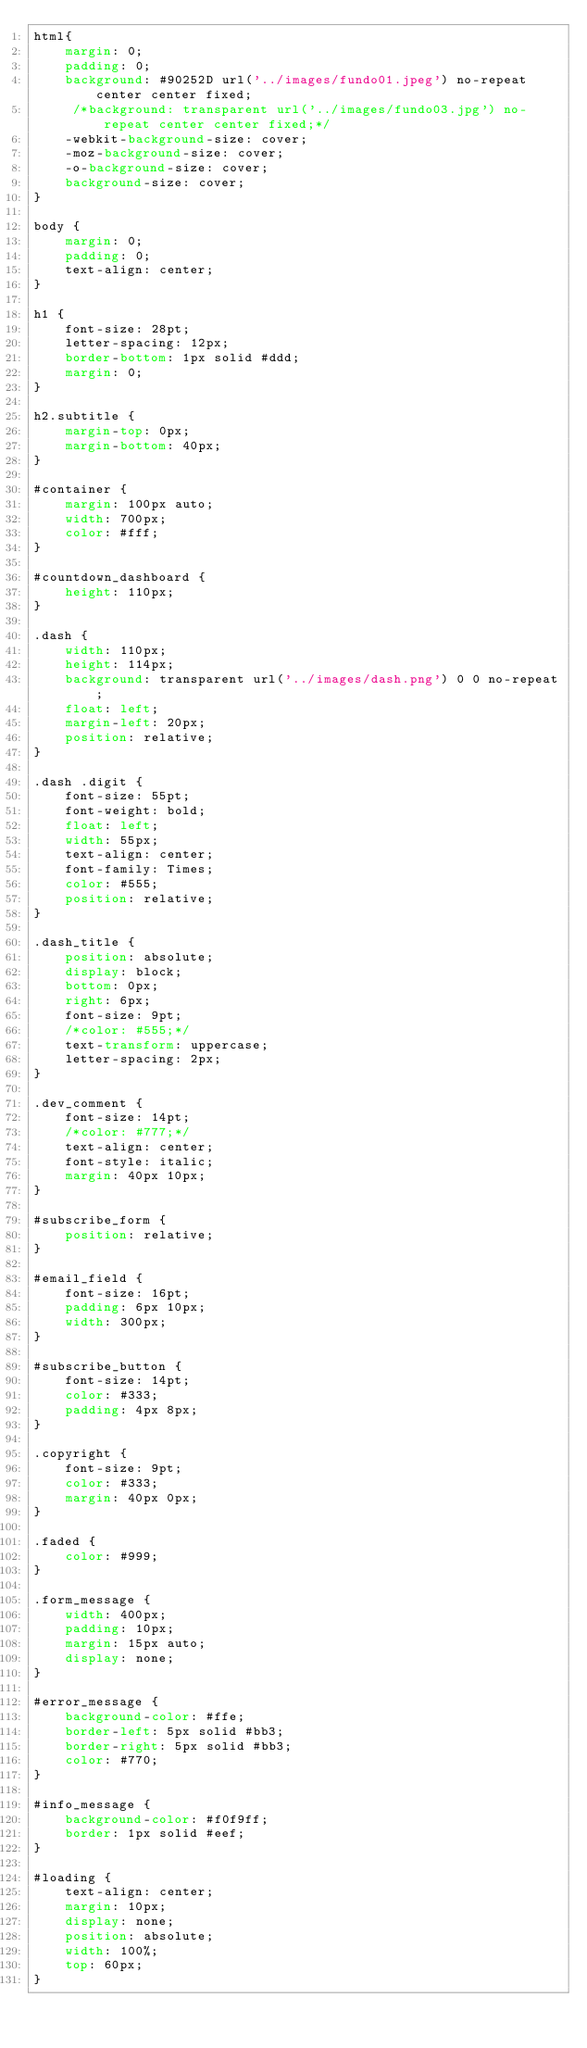<code> <loc_0><loc_0><loc_500><loc_500><_CSS_>html{
	margin: 0;
	padding: 0;
	background: #90252D url('../images/fundo01.jpeg') no-repeat center center fixed;
	 /*background: transparent url('../images/fundo03.jpg') no-repeat center center fixed;*/
	-webkit-background-size: cover;
	-moz-background-size: cover;
	-o-background-size: cover;
	background-size: cover;
}

body {
	margin: 0;
	padding: 0;
	text-align: center;
}

h1 {
	font-size: 28pt;
	letter-spacing: 12px;
	border-bottom: 1px solid #ddd;
	margin: 0;
}

h2.subtitle {
	margin-top: 0px;
	margin-bottom: 40px;
}

#container {
	margin: 100px auto;
	width: 700px;
	color: #fff;
}

#countdown_dashboard {
	height: 110px;
}

.dash {
	width: 110px;
	height: 114px;
	background: transparent url('../images/dash.png') 0 0 no-repeat;
	float: left;
	margin-left: 20px;
	position: relative;
}

.dash .digit {
	font-size: 55pt;
	font-weight: bold;
	float: left;
	width: 55px;
	text-align: center;
	font-family: Times;
	color: #555;
	position: relative;
}

.dash_title {
	position: absolute;
	display: block;
	bottom: 0px;
	right: 6px;
	font-size: 9pt;
	/*color: #555;*/
	text-transform: uppercase;
	letter-spacing: 2px;
}

.dev_comment {
	font-size: 14pt;
	/*color: #777;*/
	text-align: center;
	font-style: italic;
	margin: 40px 10px;
}

#subscribe_form {
	position: relative;
}

#email_field {
	font-size: 16pt;
	padding: 6px 10px;
	width: 300px;
}

#subscribe_button {
	font-size: 14pt;
	color: #333;
	padding: 4px 8px;
}

.copyright {
	font-size: 9pt;
	color: #333;
	margin: 40px 0px;
}

.faded {
	color: #999;
}

.form_message {
	width: 400px;
	padding: 10px;
	margin: 15px auto;
	display: none;
}

#error_message {
	background-color: #ffe;
	border-left: 5px solid #bb3;
	border-right: 5px solid #bb3;
	color: #770;
}

#info_message {
	background-color: #f0f9ff;
	border: 1px solid #eef;
}

#loading {
	text-align: center;
	margin: 10px;
	display: none;
	position: absolute;
	width: 100%;
	top: 60px;
}</code> 